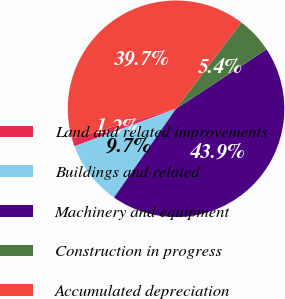Convert chart to OTSL. <chart><loc_0><loc_0><loc_500><loc_500><pie_chart><fcel>Land and related improvements<fcel>Buildings and related<fcel>Machinery and equipment<fcel>Construction in progress<fcel>Accumulated depreciation<nl><fcel>1.23%<fcel>9.66%<fcel>43.94%<fcel>5.45%<fcel>39.72%<nl></chart> 